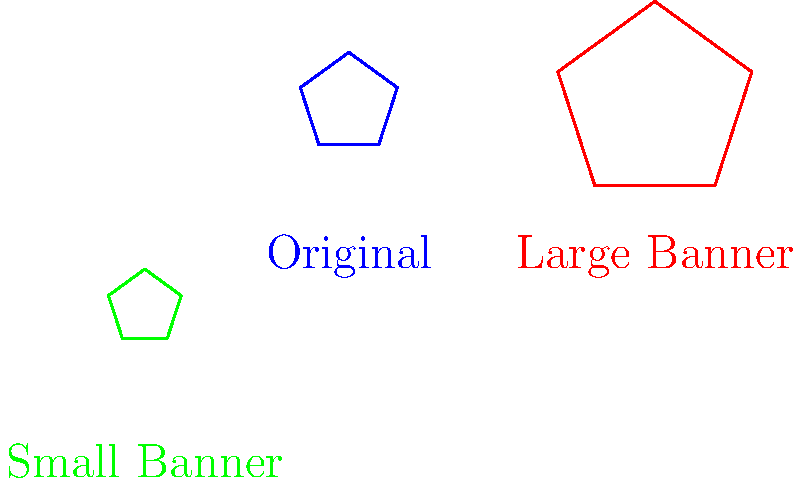As the volunteer coordinator for a local non-profit organization, you need to resize the organization's logo for different banners. The original logo is a regular pentagon with a side length of 10 inches. For a large banner, you need to scale the logo so that its side length becomes 20 inches. For a small banner, you need to scale the logo so that its side length becomes 7.5 inches. What are the scale factors for the large and small banners, respectively? To find the scale factors, we need to compare the new side lengths to the original side length:

1. For the large banner:
   - Original side length: 10 inches
   - New side length: 20 inches
   - Scale factor = New length / Original length
   - Scale factor = 20 / 10 = 2

2. For the small banner:
   - Original side length: 10 inches
   - New side length: 7.5 inches
   - Scale factor = New length / Original length
   - Scale factor = 7.5 / 10 = 0.75

Therefore, the scale factor for the large banner is 2, and the scale factor for the small banner is 0.75.
Answer: 2 and 0.75 